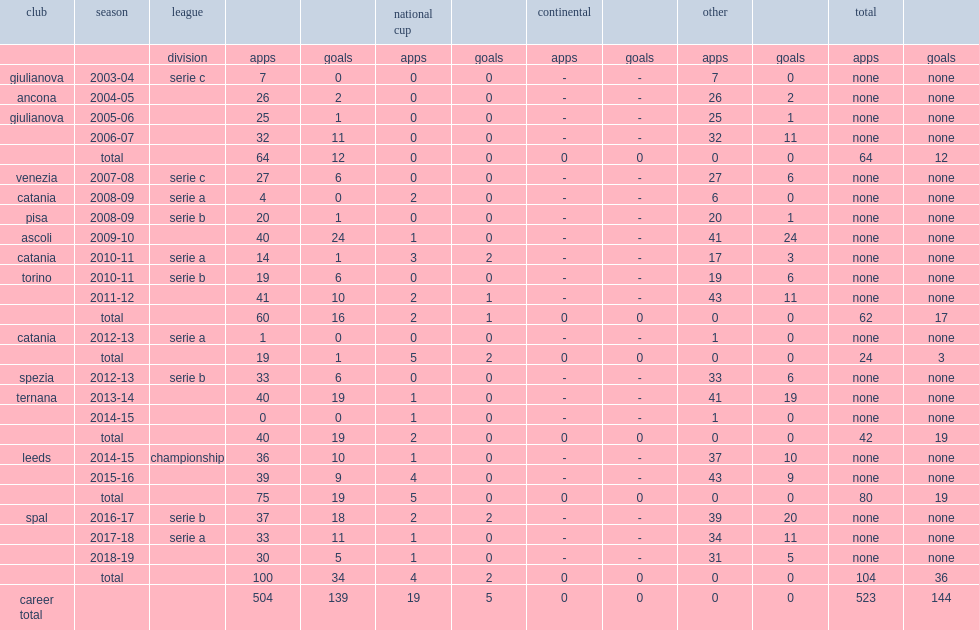Which club did mirco antenucci play for in 2010-11? Catania. 